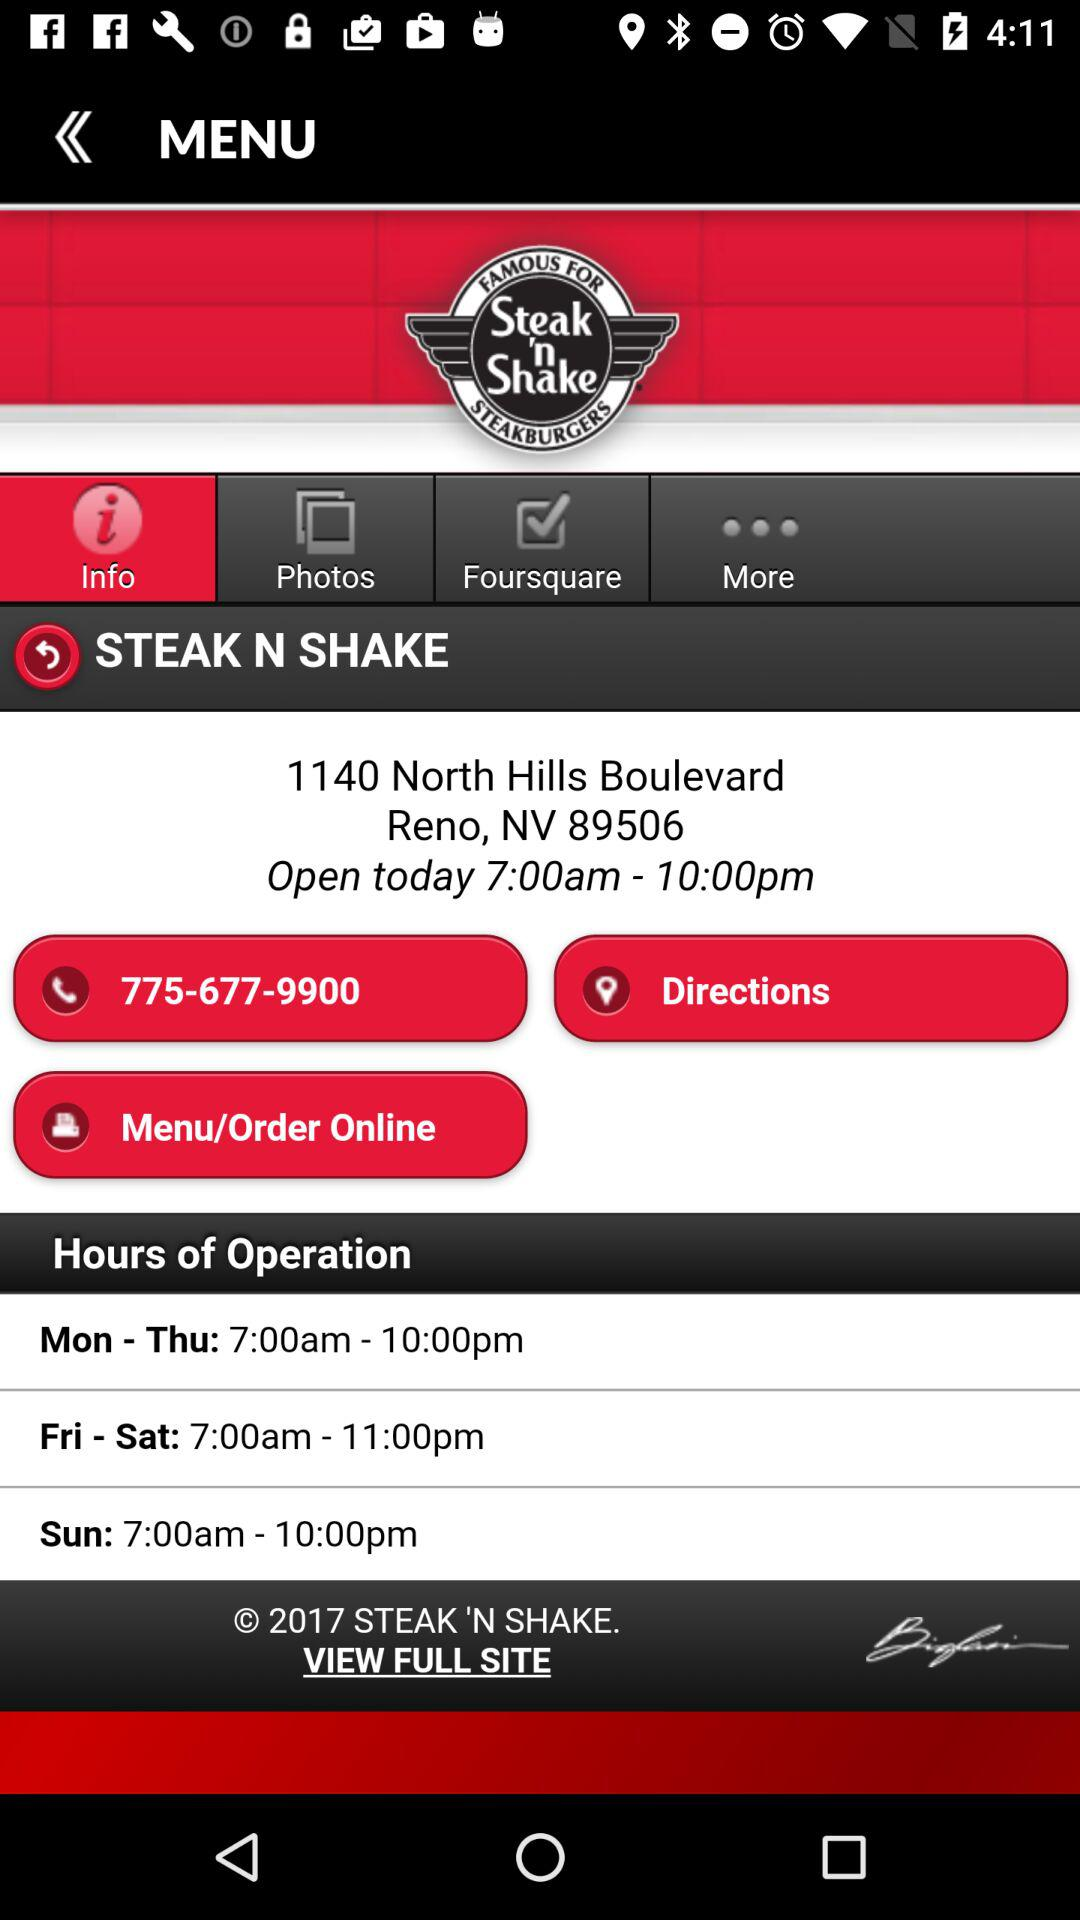What is the hour of operation on Sunday? The hours of operation on Sunday are from 7:00 a.m. to 10:00 p.m. 